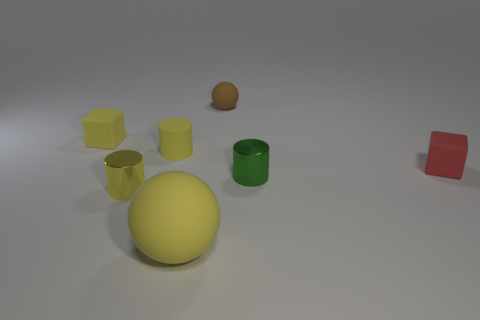What shape is the green object that is the same size as the brown rubber thing?
Keep it short and to the point. Cylinder. Is there a block of the same color as the big rubber thing?
Offer a terse response. Yes. Do the big matte ball and the matte block on the left side of the red cube have the same color?
Your answer should be very brief. Yes. There is a tiny object that is to the right of the shiny thing on the right side of the large yellow rubber sphere; what color is it?
Offer a very short reply. Red. Is there a brown object in front of the tiny cylinder in front of the small shiny thing right of the large yellow ball?
Your answer should be compact. No. The cylinder that is made of the same material as the small ball is what color?
Your response must be concise. Yellow. How many red cylinders have the same material as the big sphere?
Provide a succinct answer. 0. Do the red block and the cylinder that is on the right side of the big object have the same material?
Offer a very short reply. No. How many things are either cylinders that are behind the green metallic thing or big brown rubber cylinders?
Give a very brief answer. 1. What is the size of the cylinder to the right of the matte ball behind the cylinder that is in front of the green cylinder?
Your response must be concise. Small. 